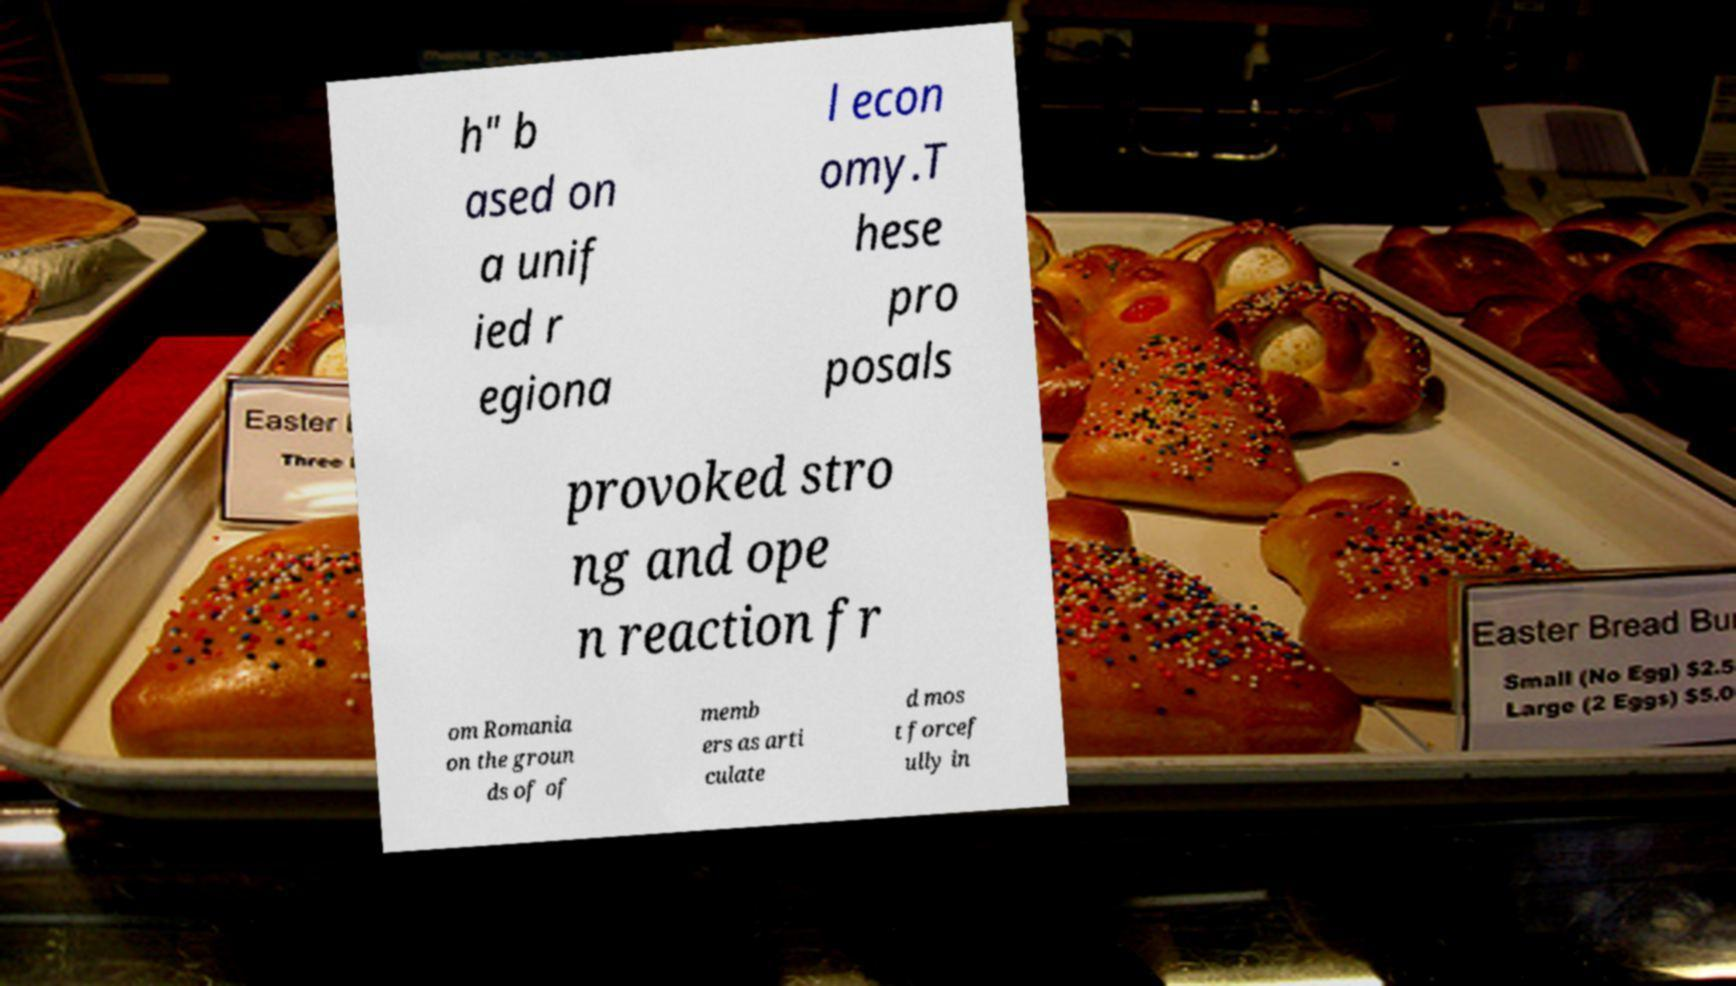I need the written content from this picture converted into text. Can you do that? h" b ased on a unif ied r egiona l econ omy.T hese pro posals provoked stro ng and ope n reaction fr om Romania on the groun ds of of memb ers as arti culate d mos t forcef ully in 